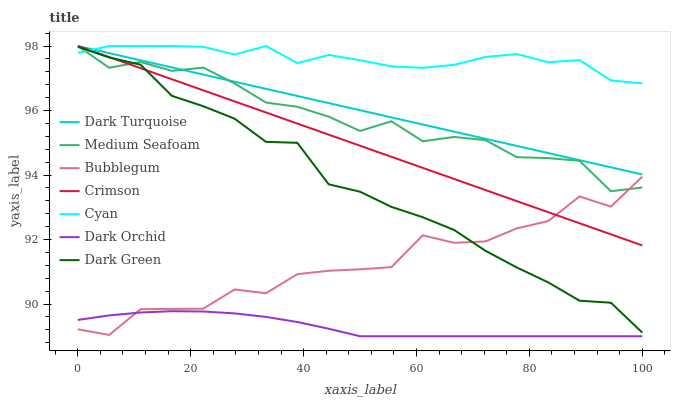Does Dark Orchid have the minimum area under the curve?
Answer yes or no. Yes. Does Cyan have the maximum area under the curve?
Answer yes or no. Yes. Does Bubblegum have the minimum area under the curve?
Answer yes or no. No. Does Bubblegum have the maximum area under the curve?
Answer yes or no. No. Is Crimson the smoothest?
Answer yes or no. Yes. Is Bubblegum the roughest?
Answer yes or no. Yes. Is Dark Orchid the smoothest?
Answer yes or no. No. Is Dark Orchid the roughest?
Answer yes or no. No. Does Dark Orchid have the lowest value?
Answer yes or no. Yes. Does Bubblegum have the lowest value?
Answer yes or no. No. Does Medium Seafoam have the highest value?
Answer yes or no. Yes. Does Bubblegum have the highest value?
Answer yes or no. No. Is Dark Orchid less than Dark Turquoise?
Answer yes or no. Yes. Is Medium Seafoam greater than Dark Orchid?
Answer yes or no. Yes. Does Dark Green intersect Bubblegum?
Answer yes or no. Yes. Is Dark Green less than Bubblegum?
Answer yes or no. No. Is Dark Green greater than Bubblegum?
Answer yes or no. No. Does Dark Orchid intersect Dark Turquoise?
Answer yes or no. No. 